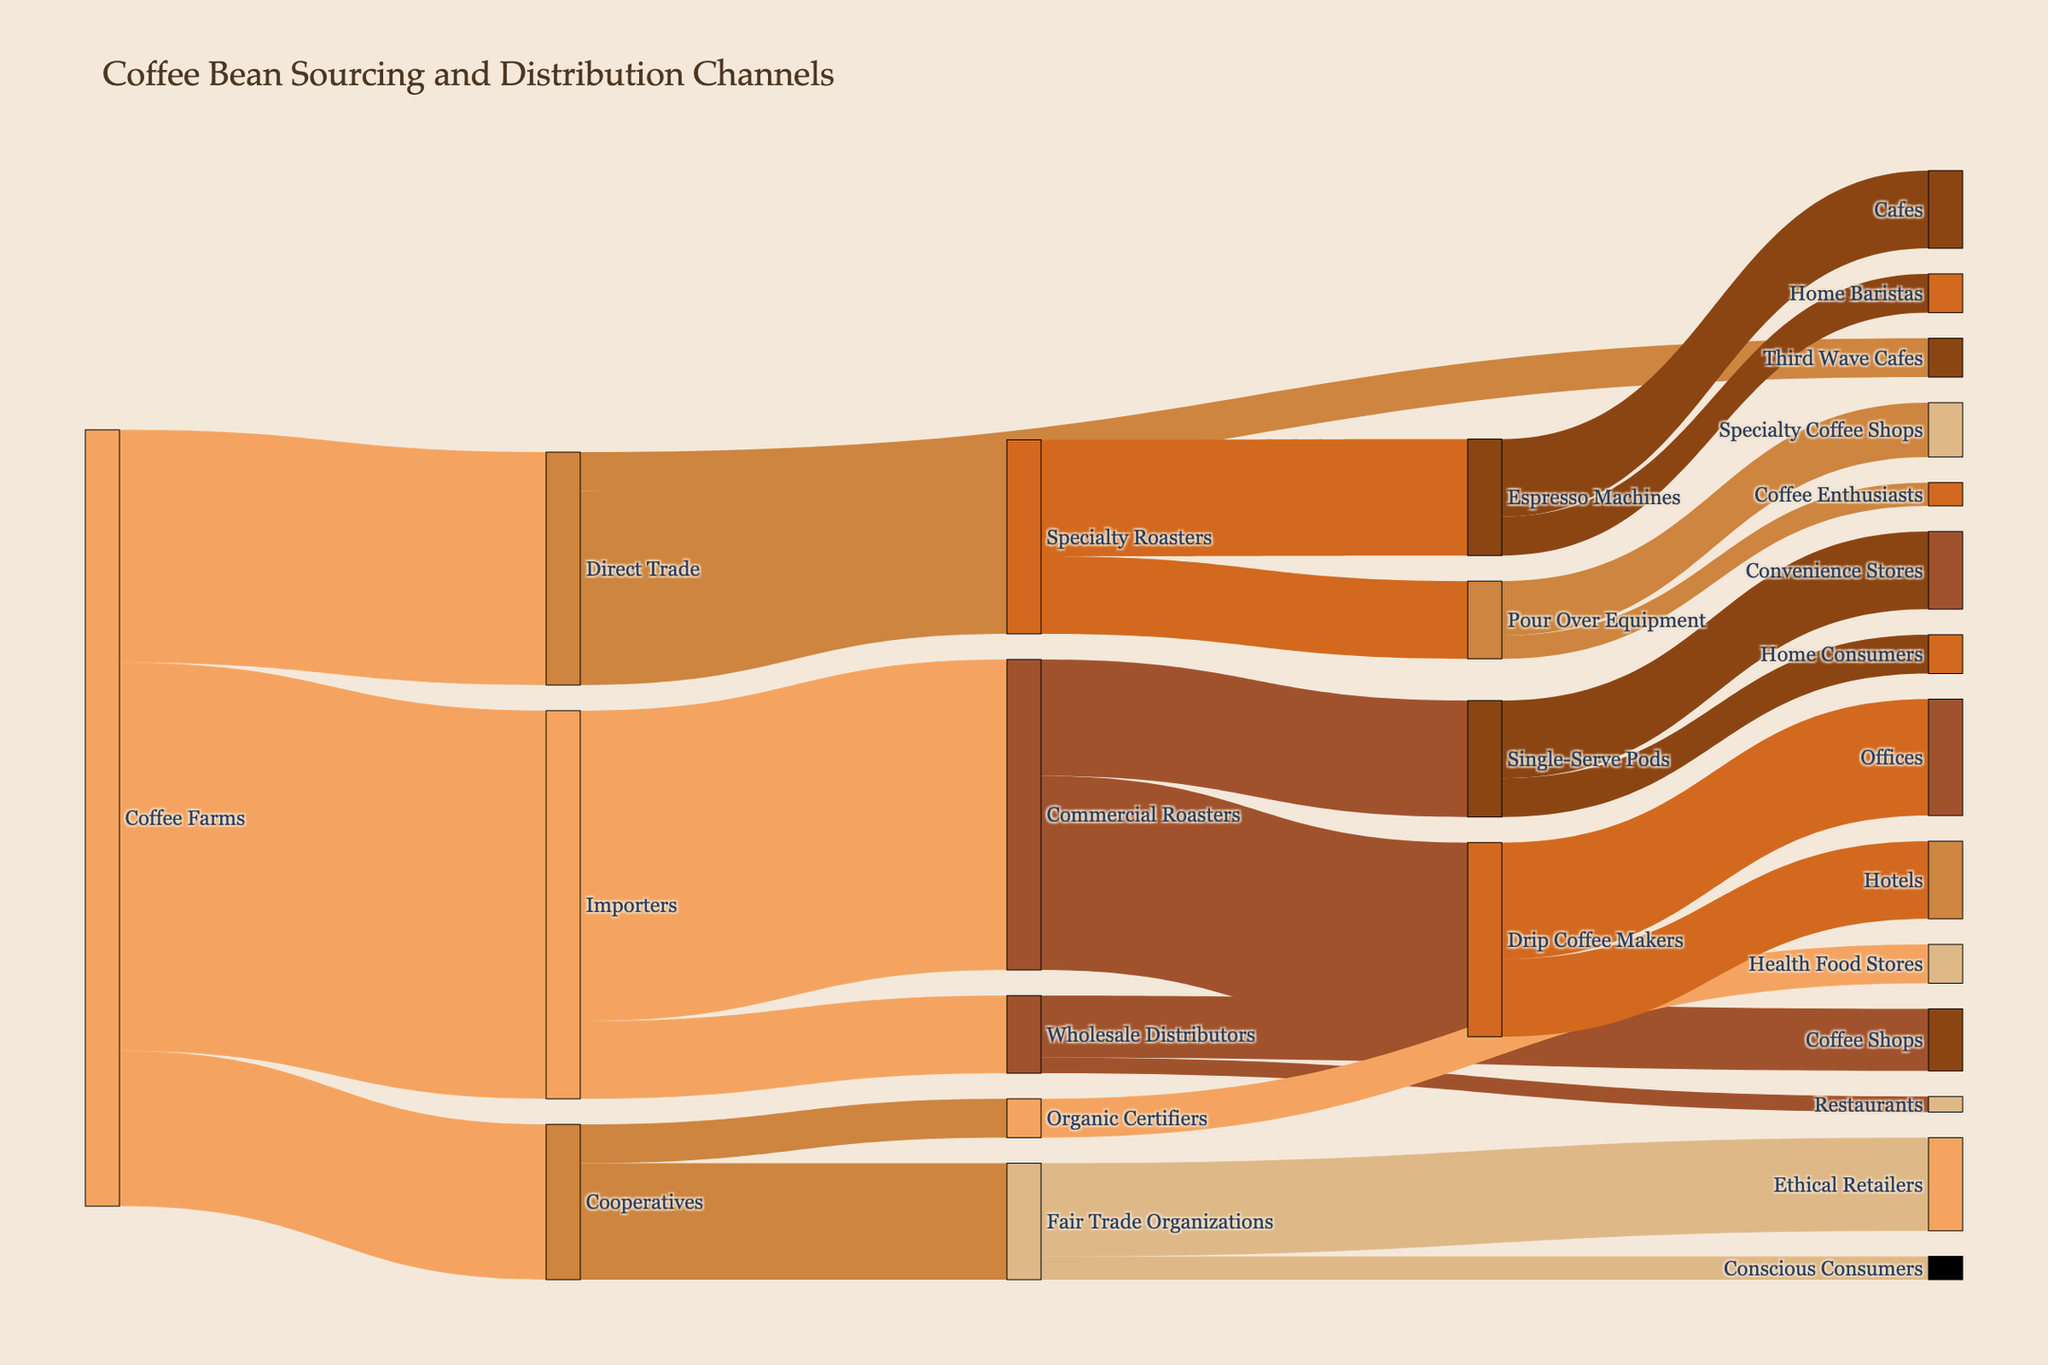What is the title of the figure? The title is usually placed at the top of the figure and provides a succinct description of what the visual data represents. It is important to quickly understand the context of the data visualized.
Answer: "Coffee Bean Sourcing and Distribution Channels" Which path has the highest value from the coffee farms? To identify the path with the highest value, look at the connections originating from 'Coffee Farms' and identify the one with the largest numeric value associated with it.
Answer: Coffee Farms to Importers (50) How many value paths are there from Direct Trade? Count the number of connections or 'paths' that originate from the 'Direct Trade' node.
Answer: 2 What is the total value of coffee flowing from Coffee Farms? Sum the values of all connections that originate from 'Coffee Farms'. The calculation is 30 (Direct Trade) + 50 (Importers) + 20 (Cooperatives).
Answer: 100 Which target receives the most value from Commercial Roasters? To determine this, compare the value of connections from 'Commercial Roasters' to its different targets. The higher number indicates the target that receives the most.
Answer: Drip Coffee Makers (25) What sources lead to Specialty Roasters and what is their combined value? Identify all the paths leading to 'Specialty Roasters' and sum up their values. The calculation is 25 (Direct Trade) + 0 (no other path).
Answer: 25 Which distribution target has the smallest associated value and what is it? Check all distribution targets in the diagram and identify the one with the lowest numerical value associated.
Answer: Restaurants (2) What is the total value flowing into Fair Trade Organizations? Sum the values from all sources that are directed to 'Fair Trade Organizations'. The calculation is 15 (Cooperatives).
Answer: 15 Which brewing method's pathway receives coffee beans from both Direct Trade and Importers? Track the paths from 'Direct Trade' and 'Importers' and see if they converge into a common brewing method.
Answer: There is no common brewing method that receives beans from both Direct Trade and Importers Compare the total value from Cooperatives to the total value from Direct Trade. Which is higher and by how much? Calculate the total values of paths originating from 'Cooperatives' and 'Direct Trade' and compare them. Cooperatives have 20, and Direct Trade has 30. The difference is 30 - 20.
Answer: Direct Trade by 10 